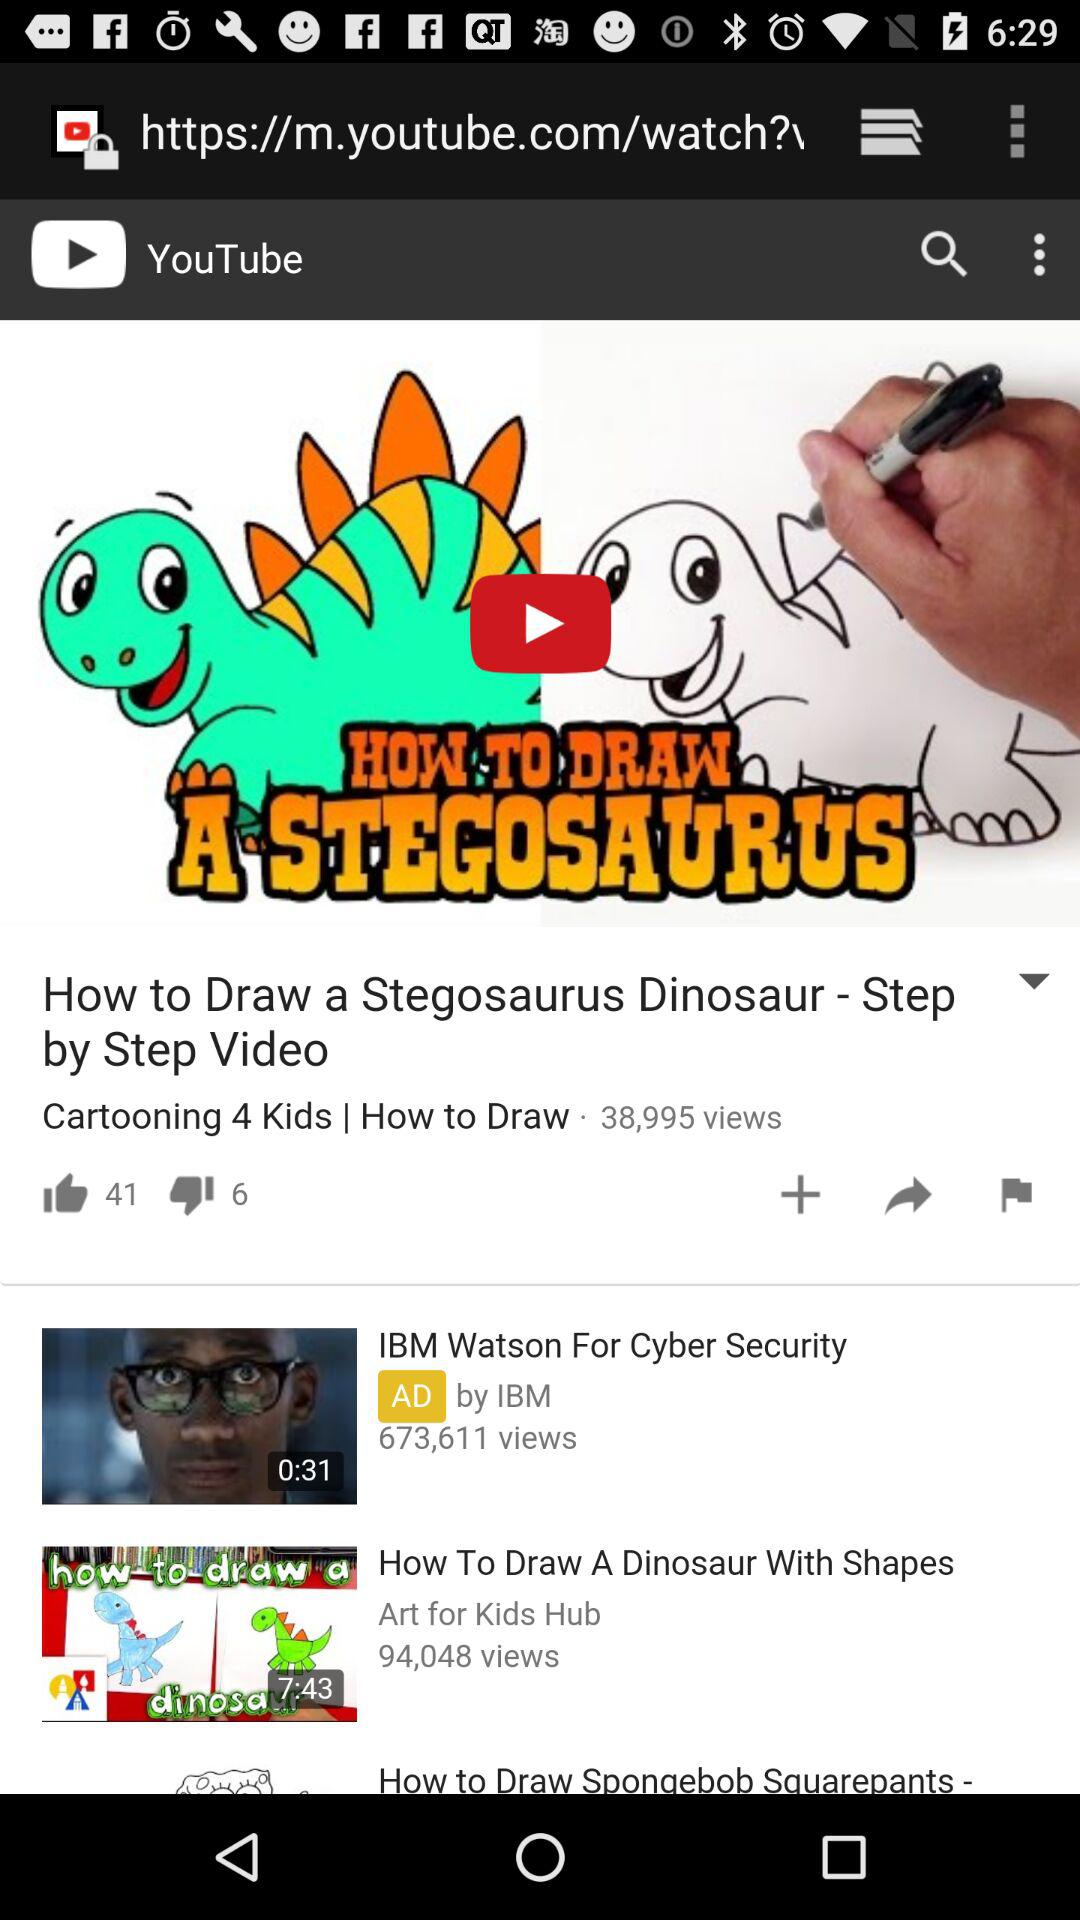What is the number of dislikes of the video "How to Draw a Stegosaurus Dinosaur"? The number of dislikes is 6. 